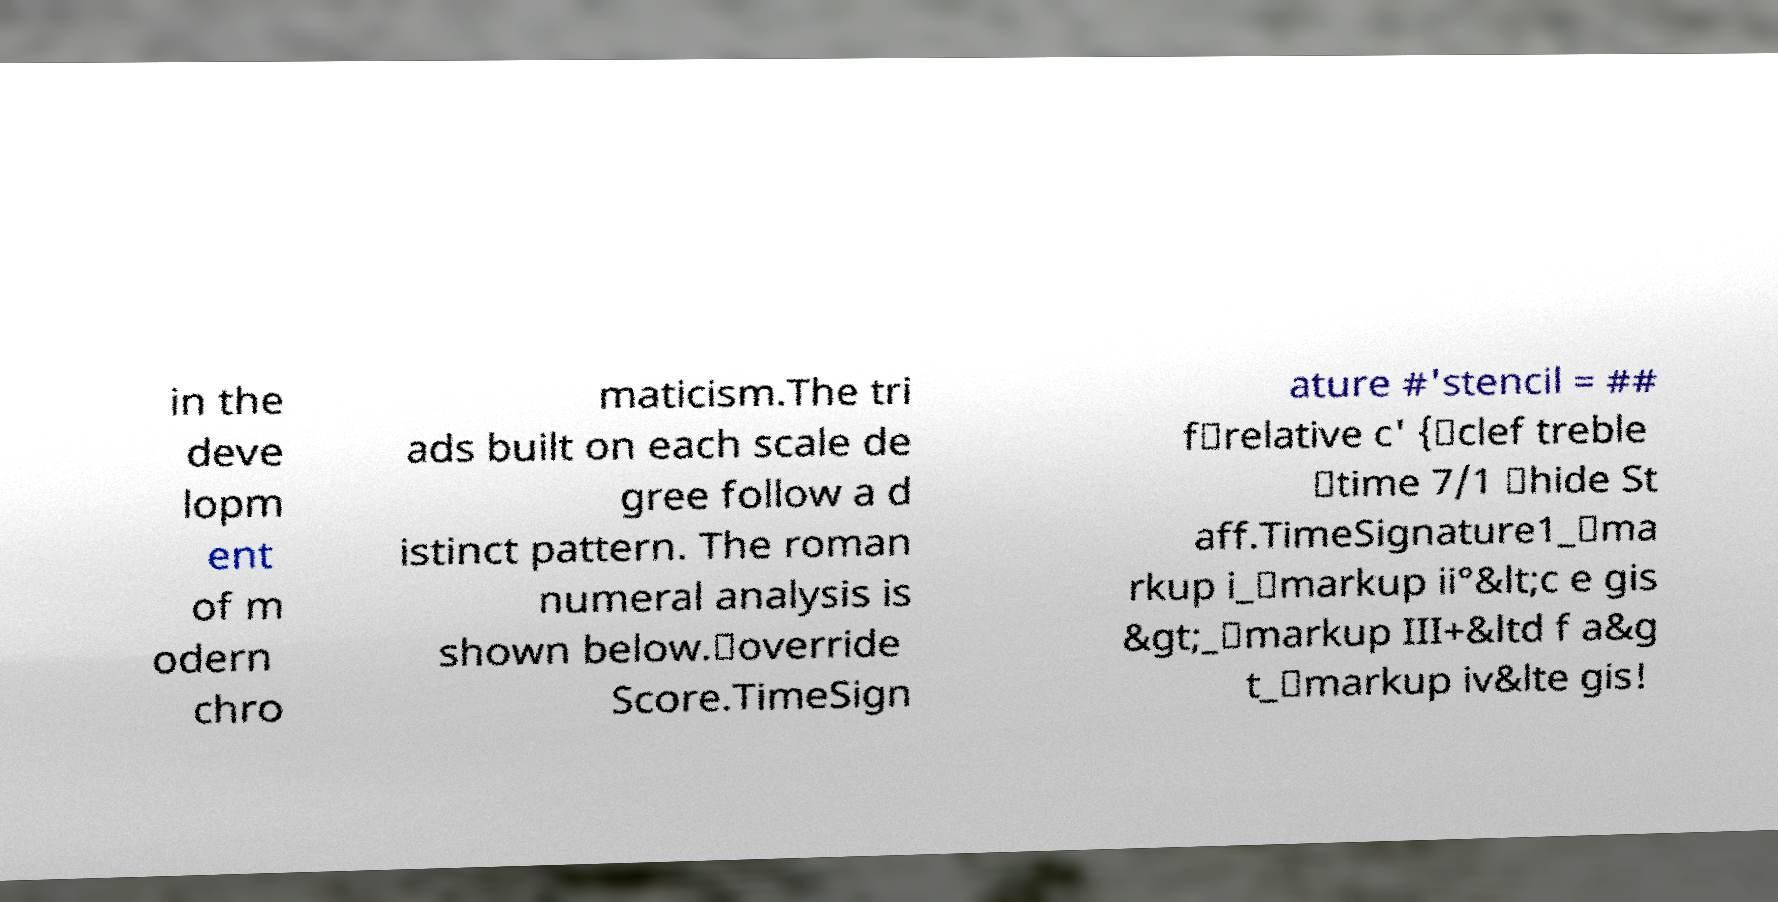Please identify and transcribe the text found in this image. in the deve lopm ent of m odern chro maticism.The tri ads built on each scale de gree follow a d istinct pattern. The roman numeral analysis is shown below.\override Score.TimeSign ature #'stencil = ## f\relative c' {\clef treble \time 7/1 \hide St aff.TimeSignature1_\ma rkup i_\markup ii°&lt;c e gis &gt;_\markup III+&ltd f a&g t_\markup iv&lte gis! 